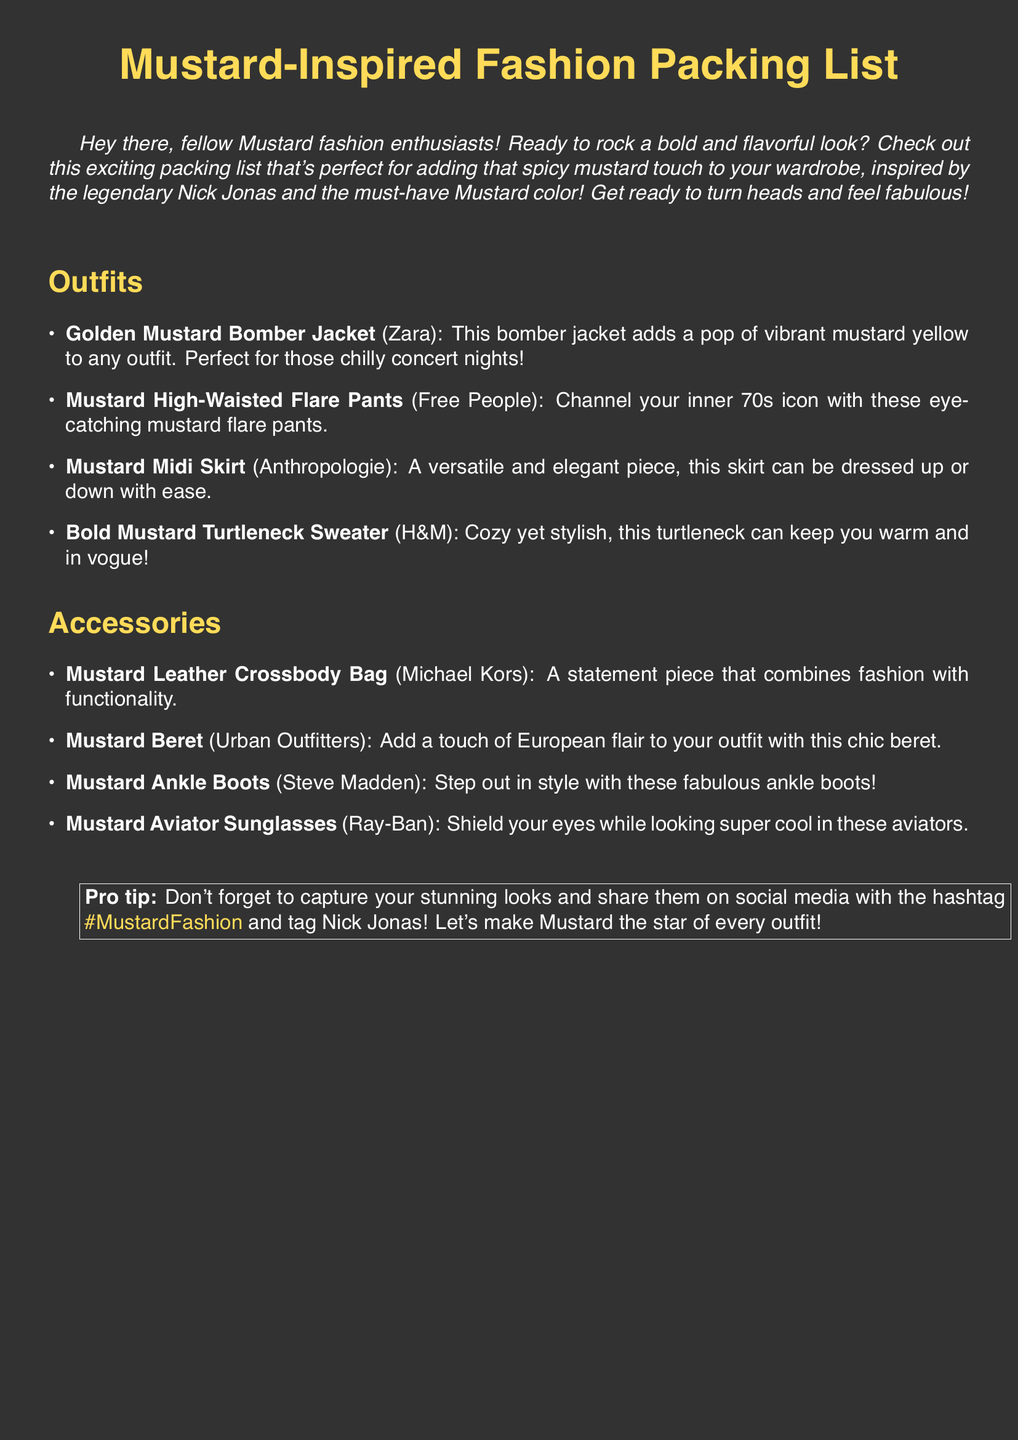What is the title of the document? The title of the document is stated prominently at the top, identifying the main focus on Mustard-inspired fashion.
Answer: Mustard-Inspired Fashion Packing List How many outfits are listed? The document includes a section titled "Outfits" that enumerates a total of four distinct outfits.
Answer: 4 What type of jacket is suggested? The packing list specifically mentions a "Golden Mustard Bomber Jacket" as an outfit option.
Answer: Bomber Jacket Which brand makes the mustard beret? The document specifies that the mustard beret is available from Urban Outfitters.
Answer: Urban Outfitters What is the color theme of the packing list? The overarching theme of the document revolves around the color mustard, which is referenced multiple times throughout.
Answer: Mustard How can you share your looks on social media? The document suggests using a specific hashtag to share outfits online, encouraging engagement within the fashion community.
Answer: #MustardFashion What accessory is suggested for shield from sunlight? The list includes "Mustard Aviator Sunglasses" as a stylish option for sun protection.
Answer: Aviator Sunglasses Which fashion item is described as cozy yet stylish? The packing list describes the "Bold Mustard Turtleneck Sweater" as both cozy and in vogue.
Answer: Turtleneck Sweater How many accessories are included in the packing list? The document presents a section titled "Accessories" that identifies four fashionable items.
Answer: 4 